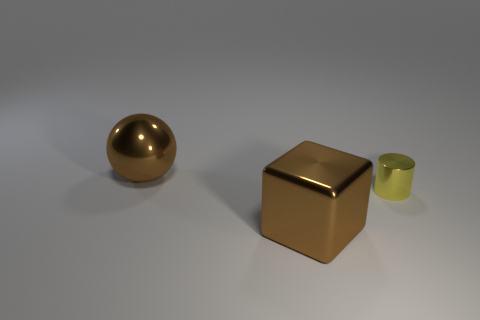Is there anything else that is the same size as the cylinder?
Offer a terse response. No. There is a brown thing that is in front of the sphere; what is its material?
Ensure brevity in your answer.  Metal. Are there an equal number of large brown balls that are in front of the tiny metal object and cylinders that are on the left side of the brown block?
Your answer should be compact. Yes. Does the metallic object that is in front of the yellow metal cylinder have the same size as the object behind the yellow cylinder?
Ensure brevity in your answer.  Yes. What number of spheres are the same color as the big block?
Provide a succinct answer. 1. What material is the object that is the same color as the metallic block?
Offer a very short reply. Metal. Are there more spheres that are behind the small object than gray metallic spheres?
Ensure brevity in your answer.  Yes. What number of tiny yellow cylinders are made of the same material as the tiny yellow object?
Your answer should be very brief. 0. Is the yellow object the same size as the brown cube?
Offer a terse response. No. What is the shape of the object that is right of the brown metallic thing in front of the big thing that is left of the cube?
Keep it short and to the point. Cylinder. 